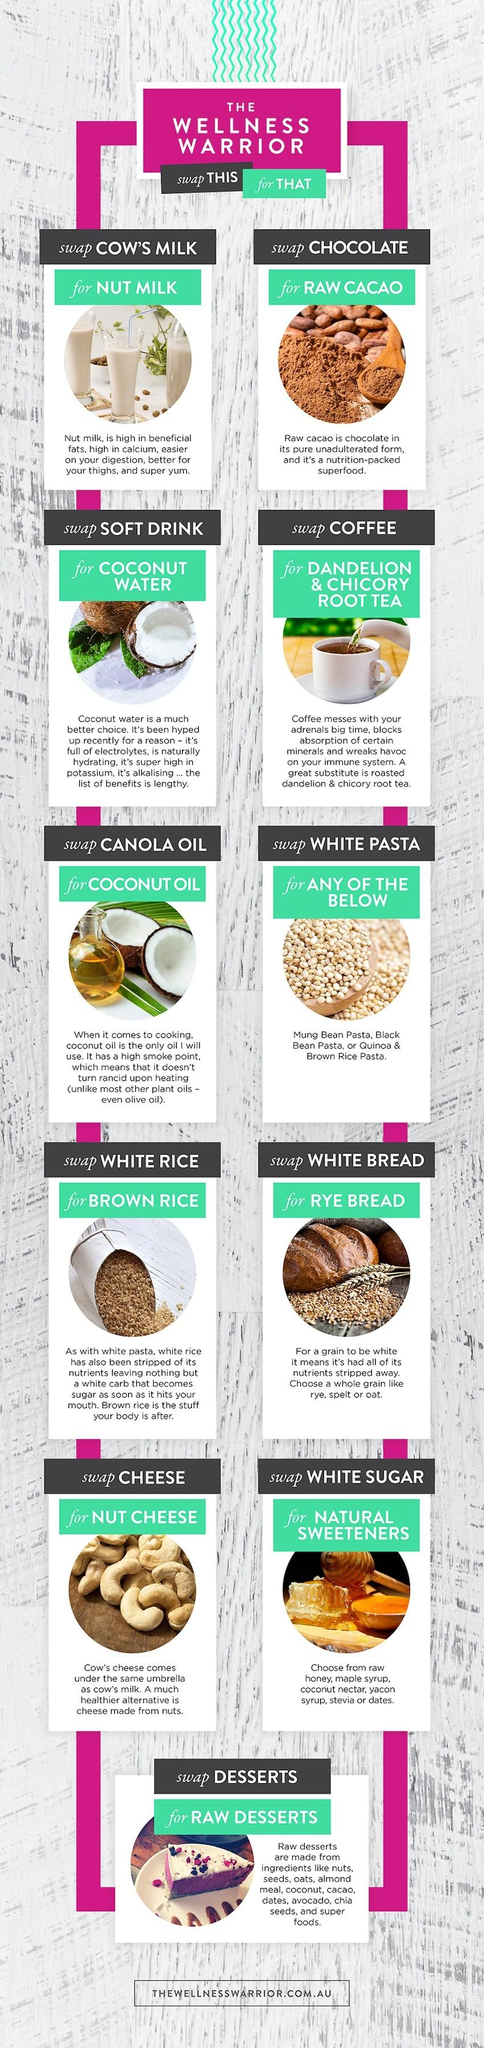Indicate a few pertinent items in this graphic. Coconut water and coconut oil are healthy foods obtained from coconuts. In place of traditional white pasta, black bean pasta is a healthier and more sustainable option. Coconut oil has a high smoke point, making it the best choice among oils with high smoke point, which includes Olive oil, Canola oil, and Coconut oil. It is necessary to replace cow's milk and cheese with nuts, as these are the products obtained from the cow that need to be swapped in order to maintain a healthy diet. There are 11 food items listed that need to be swapped. 